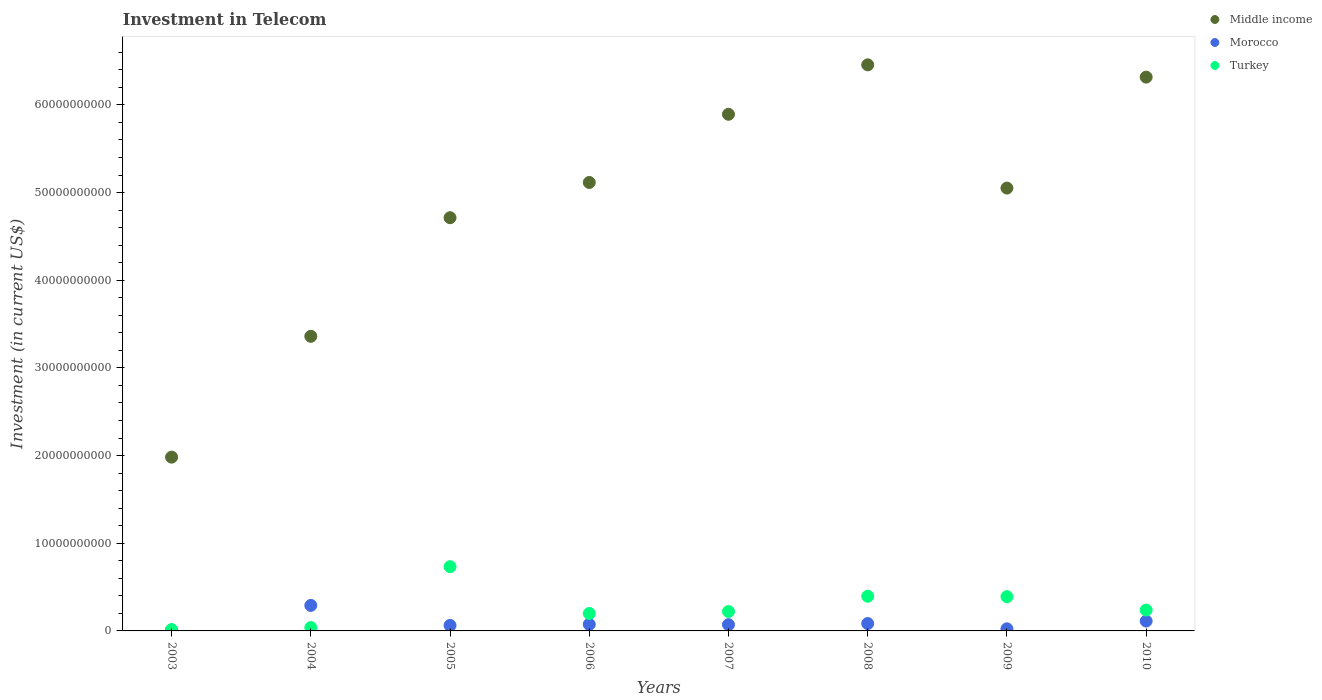Is the number of dotlines equal to the number of legend labels?
Give a very brief answer. Yes. What is the amount invested in telecom in Middle income in 2009?
Make the answer very short. 5.05e+1. Across all years, what is the maximum amount invested in telecom in Middle income?
Provide a short and direct response. 6.46e+1. Across all years, what is the minimum amount invested in telecom in Middle income?
Provide a short and direct response. 1.98e+1. In which year was the amount invested in telecom in Turkey maximum?
Provide a succinct answer. 2005. In which year was the amount invested in telecom in Turkey minimum?
Your answer should be compact. 2003. What is the total amount invested in telecom in Turkey in the graph?
Your answer should be very brief. 2.23e+1. What is the difference between the amount invested in telecom in Turkey in 2003 and that in 2005?
Your answer should be compact. -7.17e+09. What is the difference between the amount invested in telecom in Middle income in 2008 and the amount invested in telecom in Turkey in 2010?
Your answer should be compact. 6.22e+1. What is the average amount invested in telecom in Turkey per year?
Provide a succinct answer. 2.79e+09. In the year 2009, what is the difference between the amount invested in telecom in Morocco and amount invested in telecom in Turkey?
Your response must be concise. -3.67e+09. What is the ratio of the amount invested in telecom in Turkey in 2007 to that in 2009?
Offer a very short reply. 0.57. Is the amount invested in telecom in Middle income in 2003 less than that in 2004?
Your answer should be compact. Yes. What is the difference between the highest and the second highest amount invested in telecom in Morocco?
Your answer should be very brief. 1.79e+09. What is the difference between the highest and the lowest amount invested in telecom in Turkey?
Keep it short and to the point. 7.17e+09. In how many years, is the amount invested in telecom in Middle income greater than the average amount invested in telecom in Middle income taken over all years?
Offer a very short reply. 5. How many years are there in the graph?
Your answer should be compact. 8. What is the difference between two consecutive major ticks on the Y-axis?
Your answer should be very brief. 1.00e+1. Are the values on the major ticks of Y-axis written in scientific E-notation?
Your response must be concise. No. Does the graph contain any zero values?
Ensure brevity in your answer.  No. Does the graph contain grids?
Offer a very short reply. No. What is the title of the graph?
Ensure brevity in your answer.  Investment in Telecom. Does "Central African Republic" appear as one of the legend labels in the graph?
Provide a short and direct response. No. What is the label or title of the X-axis?
Make the answer very short. Years. What is the label or title of the Y-axis?
Provide a succinct answer. Investment (in current US$). What is the Investment (in current US$) in Middle income in 2003?
Provide a succinct answer. 1.98e+1. What is the Investment (in current US$) of Turkey in 2003?
Offer a very short reply. 1.55e+08. What is the Investment (in current US$) in Middle income in 2004?
Offer a very short reply. 3.36e+1. What is the Investment (in current US$) in Morocco in 2004?
Offer a terse response. 2.91e+09. What is the Investment (in current US$) of Turkey in 2004?
Your answer should be compact. 3.84e+08. What is the Investment (in current US$) of Middle income in 2005?
Offer a very short reply. 4.71e+1. What is the Investment (in current US$) of Morocco in 2005?
Ensure brevity in your answer.  6.26e+08. What is the Investment (in current US$) in Turkey in 2005?
Offer a terse response. 7.33e+09. What is the Investment (in current US$) of Middle income in 2006?
Provide a succinct answer. 5.12e+1. What is the Investment (in current US$) in Morocco in 2006?
Your answer should be compact. 7.51e+08. What is the Investment (in current US$) of Turkey in 2006?
Keep it short and to the point. 1.99e+09. What is the Investment (in current US$) of Middle income in 2007?
Provide a succinct answer. 5.89e+1. What is the Investment (in current US$) in Morocco in 2007?
Keep it short and to the point. 7.16e+08. What is the Investment (in current US$) in Turkey in 2007?
Give a very brief answer. 2.22e+09. What is the Investment (in current US$) in Middle income in 2008?
Give a very brief answer. 6.46e+1. What is the Investment (in current US$) of Morocco in 2008?
Provide a short and direct response. 8.43e+08. What is the Investment (in current US$) of Turkey in 2008?
Keep it short and to the point. 3.95e+09. What is the Investment (in current US$) of Middle income in 2009?
Keep it short and to the point. 5.05e+1. What is the Investment (in current US$) in Morocco in 2009?
Provide a succinct answer. 2.40e+08. What is the Investment (in current US$) of Turkey in 2009?
Offer a terse response. 3.91e+09. What is the Investment (in current US$) of Middle income in 2010?
Your answer should be compact. 6.32e+1. What is the Investment (in current US$) of Morocco in 2010?
Provide a succinct answer. 1.12e+09. What is the Investment (in current US$) of Turkey in 2010?
Your answer should be very brief. 2.38e+09. Across all years, what is the maximum Investment (in current US$) of Middle income?
Ensure brevity in your answer.  6.46e+1. Across all years, what is the maximum Investment (in current US$) of Morocco?
Offer a very short reply. 2.91e+09. Across all years, what is the maximum Investment (in current US$) of Turkey?
Offer a terse response. 7.33e+09. Across all years, what is the minimum Investment (in current US$) of Middle income?
Ensure brevity in your answer.  1.98e+1. Across all years, what is the minimum Investment (in current US$) of Turkey?
Give a very brief answer. 1.55e+08. What is the total Investment (in current US$) in Middle income in the graph?
Offer a terse response. 3.89e+11. What is the total Investment (in current US$) of Morocco in the graph?
Provide a succinct answer. 7.31e+09. What is the total Investment (in current US$) of Turkey in the graph?
Your answer should be compact. 2.23e+1. What is the difference between the Investment (in current US$) in Middle income in 2003 and that in 2004?
Your answer should be compact. -1.38e+1. What is the difference between the Investment (in current US$) of Morocco in 2003 and that in 2004?
Provide a short and direct response. -2.81e+09. What is the difference between the Investment (in current US$) in Turkey in 2003 and that in 2004?
Keep it short and to the point. -2.29e+08. What is the difference between the Investment (in current US$) in Middle income in 2003 and that in 2005?
Offer a terse response. -2.73e+1. What is the difference between the Investment (in current US$) in Morocco in 2003 and that in 2005?
Provide a short and direct response. -5.26e+08. What is the difference between the Investment (in current US$) in Turkey in 2003 and that in 2005?
Your answer should be compact. -7.17e+09. What is the difference between the Investment (in current US$) in Middle income in 2003 and that in 2006?
Make the answer very short. -3.13e+1. What is the difference between the Investment (in current US$) of Morocco in 2003 and that in 2006?
Give a very brief answer. -6.51e+08. What is the difference between the Investment (in current US$) in Turkey in 2003 and that in 2006?
Provide a succinct answer. -1.84e+09. What is the difference between the Investment (in current US$) in Middle income in 2003 and that in 2007?
Provide a succinct answer. -3.91e+1. What is the difference between the Investment (in current US$) in Morocco in 2003 and that in 2007?
Make the answer very short. -6.16e+08. What is the difference between the Investment (in current US$) of Turkey in 2003 and that in 2007?
Make the answer very short. -2.06e+09. What is the difference between the Investment (in current US$) in Middle income in 2003 and that in 2008?
Offer a terse response. -4.48e+1. What is the difference between the Investment (in current US$) of Morocco in 2003 and that in 2008?
Provide a succinct answer. -7.43e+08. What is the difference between the Investment (in current US$) of Turkey in 2003 and that in 2008?
Your answer should be very brief. -3.80e+09. What is the difference between the Investment (in current US$) of Middle income in 2003 and that in 2009?
Ensure brevity in your answer.  -3.07e+1. What is the difference between the Investment (in current US$) in Morocco in 2003 and that in 2009?
Offer a terse response. -1.40e+08. What is the difference between the Investment (in current US$) in Turkey in 2003 and that in 2009?
Give a very brief answer. -3.75e+09. What is the difference between the Investment (in current US$) in Middle income in 2003 and that in 2010?
Ensure brevity in your answer.  -4.34e+1. What is the difference between the Investment (in current US$) of Morocco in 2003 and that in 2010?
Keep it short and to the point. -1.02e+09. What is the difference between the Investment (in current US$) in Turkey in 2003 and that in 2010?
Provide a succinct answer. -2.23e+09. What is the difference between the Investment (in current US$) in Middle income in 2004 and that in 2005?
Keep it short and to the point. -1.35e+1. What is the difference between the Investment (in current US$) of Morocco in 2004 and that in 2005?
Provide a short and direct response. 2.28e+09. What is the difference between the Investment (in current US$) of Turkey in 2004 and that in 2005?
Offer a terse response. -6.95e+09. What is the difference between the Investment (in current US$) in Middle income in 2004 and that in 2006?
Give a very brief answer. -1.75e+1. What is the difference between the Investment (in current US$) of Morocco in 2004 and that in 2006?
Your response must be concise. 2.16e+09. What is the difference between the Investment (in current US$) of Turkey in 2004 and that in 2006?
Your answer should be very brief. -1.61e+09. What is the difference between the Investment (in current US$) in Middle income in 2004 and that in 2007?
Your answer should be compact. -2.53e+1. What is the difference between the Investment (in current US$) in Morocco in 2004 and that in 2007?
Ensure brevity in your answer.  2.19e+09. What is the difference between the Investment (in current US$) in Turkey in 2004 and that in 2007?
Give a very brief answer. -1.83e+09. What is the difference between the Investment (in current US$) of Middle income in 2004 and that in 2008?
Offer a very short reply. -3.10e+1. What is the difference between the Investment (in current US$) of Morocco in 2004 and that in 2008?
Give a very brief answer. 2.07e+09. What is the difference between the Investment (in current US$) in Turkey in 2004 and that in 2008?
Provide a short and direct response. -3.57e+09. What is the difference between the Investment (in current US$) of Middle income in 2004 and that in 2009?
Keep it short and to the point. -1.69e+1. What is the difference between the Investment (in current US$) in Morocco in 2004 and that in 2009?
Offer a very short reply. 2.67e+09. What is the difference between the Investment (in current US$) of Turkey in 2004 and that in 2009?
Offer a very short reply. -3.52e+09. What is the difference between the Investment (in current US$) in Middle income in 2004 and that in 2010?
Ensure brevity in your answer.  -2.96e+1. What is the difference between the Investment (in current US$) in Morocco in 2004 and that in 2010?
Your answer should be compact. 1.79e+09. What is the difference between the Investment (in current US$) in Turkey in 2004 and that in 2010?
Provide a succinct answer. -2.00e+09. What is the difference between the Investment (in current US$) of Middle income in 2005 and that in 2006?
Provide a short and direct response. -4.02e+09. What is the difference between the Investment (in current US$) in Morocco in 2005 and that in 2006?
Your response must be concise. -1.25e+08. What is the difference between the Investment (in current US$) of Turkey in 2005 and that in 2006?
Provide a short and direct response. 5.34e+09. What is the difference between the Investment (in current US$) of Middle income in 2005 and that in 2007?
Make the answer very short. -1.18e+1. What is the difference between the Investment (in current US$) in Morocco in 2005 and that in 2007?
Your answer should be compact. -9.00e+07. What is the difference between the Investment (in current US$) of Turkey in 2005 and that in 2007?
Provide a short and direct response. 5.11e+09. What is the difference between the Investment (in current US$) in Middle income in 2005 and that in 2008?
Give a very brief answer. -1.74e+1. What is the difference between the Investment (in current US$) of Morocco in 2005 and that in 2008?
Offer a very short reply. -2.17e+08. What is the difference between the Investment (in current US$) in Turkey in 2005 and that in 2008?
Your answer should be very brief. 3.37e+09. What is the difference between the Investment (in current US$) of Middle income in 2005 and that in 2009?
Provide a short and direct response. -3.38e+09. What is the difference between the Investment (in current US$) in Morocco in 2005 and that in 2009?
Provide a short and direct response. 3.86e+08. What is the difference between the Investment (in current US$) of Turkey in 2005 and that in 2009?
Provide a short and direct response. 3.42e+09. What is the difference between the Investment (in current US$) of Middle income in 2005 and that in 2010?
Provide a short and direct response. -1.60e+1. What is the difference between the Investment (in current US$) in Morocco in 2005 and that in 2010?
Keep it short and to the point. -4.98e+08. What is the difference between the Investment (in current US$) in Turkey in 2005 and that in 2010?
Your answer should be very brief. 4.95e+09. What is the difference between the Investment (in current US$) of Middle income in 2006 and that in 2007?
Ensure brevity in your answer.  -7.78e+09. What is the difference between the Investment (in current US$) of Morocco in 2006 and that in 2007?
Offer a terse response. 3.46e+07. What is the difference between the Investment (in current US$) in Turkey in 2006 and that in 2007?
Offer a very short reply. -2.23e+08. What is the difference between the Investment (in current US$) in Middle income in 2006 and that in 2008?
Your response must be concise. -1.34e+1. What is the difference between the Investment (in current US$) in Morocco in 2006 and that in 2008?
Offer a very short reply. -9.24e+07. What is the difference between the Investment (in current US$) of Turkey in 2006 and that in 2008?
Offer a very short reply. -1.96e+09. What is the difference between the Investment (in current US$) in Middle income in 2006 and that in 2009?
Offer a terse response. 6.40e+08. What is the difference between the Investment (in current US$) in Morocco in 2006 and that in 2009?
Your response must be concise. 5.11e+08. What is the difference between the Investment (in current US$) in Turkey in 2006 and that in 2009?
Offer a very short reply. -1.92e+09. What is the difference between the Investment (in current US$) in Middle income in 2006 and that in 2010?
Ensure brevity in your answer.  -1.20e+1. What is the difference between the Investment (in current US$) in Morocco in 2006 and that in 2010?
Keep it short and to the point. -3.73e+08. What is the difference between the Investment (in current US$) in Turkey in 2006 and that in 2010?
Offer a terse response. -3.89e+08. What is the difference between the Investment (in current US$) in Middle income in 2007 and that in 2008?
Your answer should be compact. -5.64e+09. What is the difference between the Investment (in current US$) of Morocco in 2007 and that in 2008?
Your response must be concise. -1.27e+08. What is the difference between the Investment (in current US$) of Turkey in 2007 and that in 2008?
Make the answer very short. -1.74e+09. What is the difference between the Investment (in current US$) of Middle income in 2007 and that in 2009?
Your response must be concise. 8.42e+09. What is the difference between the Investment (in current US$) in Morocco in 2007 and that in 2009?
Your answer should be compact. 4.76e+08. What is the difference between the Investment (in current US$) of Turkey in 2007 and that in 2009?
Your answer should be very brief. -1.69e+09. What is the difference between the Investment (in current US$) of Middle income in 2007 and that in 2010?
Offer a terse response. -4.24e+09. What is the difference between the Investment (in current US$) of Morocco in 2007 and that in 2010?
Your answer should be very brief. -4.08e+08. What is the difference between the Investment (in current US$) of Turkey in 2007 and that in 2010?
Make the answer very short. -1.66e+08. What is the difference between the Investment (in current US$) in Middle income in 2008 and that in 2009?
Provide a short and direct response. 1.41e+1. What is the difference between the Investment (in current US$) of Morocco in 2008 and that in 2009?
Offer a very short reply. 6.03e+08. What is the difference between the Investment (in current US$) in Turkey in 2008 and that in 2009?
Your answer should be very brief. 4.60e+07. What is the difference between the Investment (in current US$) in Middle income in 2008 and that in 2010?
Your response must be concise. 1.40e+09. What is the difference between the Investment (in current US$) of Morocco in 2008 and that in 2010?
Offer a terse response. -2.81e+08. What is the difference between the Investment (in current US$) of Turkey in 2008 and that in 2010?
Ensure brevity in your answer.  1.57e+09. What is the difference between the Investment (in current US$) in Middle income in 2009 and that in 2010?
Your response must be concise. -1.27e+1. What is the difference between the Investment (in current US$) of Morocco in 2009 and that in 2010?
Keep it short and to the point. -8.84e+08. What is the difference between the Investment (in current US$) of Turkey in 2009 and that in 2010?
Give a very brief answer. 1.53e+09. What is the difference between the Investment (in current US$) of Middle income in 2003 and the Investment (in current US$) of Morocco in 2004?
Your answer should be very brief. 1.69e+1. What is the difference between the Investment (in current US$) in Middle income in 2003 and the Investment (in current US$) in Turkey in 2004?
Offer a terse response. 1.94e+1. What is the difference between the Investment (in current US$) of Morocco in 2003 and the Investment (in current US$) of Turkey in 2004?
Your answer should be very brief. -2.84e+08. What is the difference between the Investment (in current US$) in Middle income in 2003 and the Investment (in current US$) in Morocco in 2005?
Make the answer very short. 1.92e+1. What is the difference between the Investment (in current US$) of Middle income in 2003 and the Investment (in current US$) of Turkey in 2005?
Offer a very short reply. 1.25e+1. What is the difference between the Investment (in current US$) in Morocco in 2003 and the Investment (in current US$) in Turkey in 2005?
Keep it short and to the point. -7.23e+09. What is the difference between the Investment (in current US$) in Middle income in 2003 and the Investment (in current US$) in Morocco in 2006?
Your response must be concise. 1.91e+1. What is the difference between the Investment (in current US$) of Middle income in 2003 and the Investment (in current US$) of Turkey in 2006?
Your answer should be very brief. 1.78e+1. What is the difference between the Investment (in current US$) of Morocco in 2003 and the Investment (in current US$) of Turkey in 2006?
Your answer should be compact. -1.89e+09. What is the difference between the Investment (in current US$) of Middle income in 2003 and the Investment (in current US$) of Morocco in 2007?
Make the answer very short. 1.91e+1. What is the difference between the Investment (in current US$) in Middle income in 2003 and the Investment (in current US$) in Turkey in 2007?
Offer a very short reply. 1.76e+1. What is the difference between the Investment (in current US$) in Morocco in 2003 and the Investment (in current US$) in Turkey in 2007?
Offer a terse response. -2.12e+09. What is the difference between the Investment (in current US$) in Middle income in 2003 and the Investment (in current US$) in Morocco in 2008?
Ensure brevity in your answer.  1.90e+1. What is the difference between the Investment (in current US$) in Middle income in 2003 and the Investment (in current US$) in Turkey in 2008?
Your response must be concise. 1.59e+1. What is the difference between the Investment (in current US$) in Morocco in 2003 and the Investment (in current US$) in Turkey in 2008?
Your response must be concise. -3.85e+09. What is the difference between the Investment (in current US$) in Middle income in 2003 and the Investment (in current US$) in Morocco in 2009?
Your response must be concise. 1.96e+1. What is the difference between the Investment (in current US$) of Middle income in 2003 and the Investment (in current US$) of Turkey in 2009?
Your answer should be very brief. 1.59e+1. What is the difference between the Investment (in current US$) of Morocco in 2003 and the Investment (in current US$) of Turkey in 2009?
Keep it short and to the point. -3.81e+09. What is the difference between the Investment (in current US$) in Middle income in 2003 and the Investment (in current US$) in Morocco in 2010?
Your response must be concise. 1.87e+1. What is the difference between the Investment (in current US$) of Middle income in 2003 and the Investment (in current US$) of Turkey in 2010?
Make the answer very short. 1.74e+1. What is the difference between the Investment (in current US$) in Morocco in 2003 and the Investment (in current US$) in Turkey in 2010?
Make the answer very short. -2.28e+09. What is the difference between the Investment (in current US$) of Middle income in 2004 and the Investment (in current US$) of Morocco in 2005?
Offer a terse response. 3.30e+1. What is the difference between the Investment (in current US$) in Middle income in 2004 and the Investment (in current US$) in Turkey in 2005?
Offer a very short reply. 2.63e+1. What is the difference between the Investment (in current US$) of Morocco in 2004 and the Investment (in current US$) of Turkey in 2005?
Give a very brief answer. -4.42e+09. What is the difference between the Investment (in current US$) in Middle income in 2004 and the Investment (in current US$) in Morocco in 2006?
Offer a very short reply. 3.29e+1. What is the difference between the Investment (in current US$) in Middle income in 2004 and the Investment (in current US$) in Turkey in 2006?
Provide a succinct answer. 3.16e+1. What is the difference between the Investment (in current US$) of Morocco in 2004 and the Investment (in current US$) of Turkey in 2006?
Give a very brief answer. 9.19e+08. What is the difference between the Investment (in current US$) in Middle income in 2004 and the Investment (in current US$) in Morocco in 2007?
Your answer should be compact. 3.29e+1. What is the difference between the Investment (in current US$) of Middle income in 2004 and the Investment (in current US$) of Turkey in 2007?
Your answer should be compact. 3.14e+1. What is the difference between the Investment (in current US$) of Morocco in 2004 and the Investment (in current US$) of Turkey in 2007?
Offer a very short reply. 6.96e+08. What is the difference between the Investment (in current US$) in Middle income in 2004 and the Investment (in current US$) in Morocco in 2008?
Give a very brief answer. 3.28e+1. What is the difference between the Investment (in current US$) of Middle income in 2004 and the Investment (in current US$) of Turkey in 2008?
Your answer should be very brief. 2.97e+1. What is the difference between the Investment (in current US$) of Morocco in 2004 and the Investment (in current US$) of Turkey in 2008?
Your answer should be compact. -1.04e+09. What is the difference between the Investment (in current US$) of Middle income in 2004 and the Investment (in current US$) of Morocco in 2009?
Ensure brevity in your answer.  3.34e+1. What is the difference between the Investment (in current US$) in Middle income in 2004 and the Investment (in current US$) in Turkey in 2009?
Your answer should be very brief. 2.97e+1. What is the difference between the Investment (in current US$) of Morocco in 2004 and the Investment (in current US$) of Turkey in 2009?
Give a very brief answer. -9.98e+08. What is the difference between the Investment (in current US$) in Middle income in 2004 and the Investment (in current US$) in Morocco in 2010?
Provide a short and direct response. 3.25e+1. What is the difference between the Investment (in current US$) in Middle income in 2004 and the Investment (in current US$) in Turkey in 2010?
Your answer should be compact. 3.12e+1. What is the difference between the Investment (in current US$) of Morocco in 2004 and the Investment (in current US$) of Turkey in 2010?
Offer a very short reply. 5.30e+08. What is the difference between the Investment (in current US$) in Middle income in 2005 and the Investment (in current US$) in Morocco in 2006?
Give a very brief answer. 4.64e+1. What is the difference between the Investment (in current US$) in Middle income in 2005 and the Investment (in current US$) in Turkey in 2006?
Give a very brief answer. 4.51e+1. What is the difference between the Investment (in current US$) in Morocco in 2005 and the Investment (in current US$) in Turkey in 2006?
Offer a terse response. -1.37e+09. What is the difference between the Investment (in current US$) of Middle income in 2005 and the Investment (in current US$) of Morocco in 2007?
Your answer should be very brief. 4.64e+1. What is the difference between the Investment (in current US$) in Middle income in 2005 and the Investment (in current US$) in Turkey in 2007?
Provide a succinct answer. 4.49e+1. What is the difference between the Investment (in current US$) of Morocco in 2005 and the Investment (in current US$) of Turkey in 2007?
Provide a succinct answer. -1.59e+09. What is the difference between the Investment (in current US$) in Middle income in 2005 and the Investment (in current US$) in Morocco in 2008?
Give a very brief answer. 4.63e+1. What is the difference between the Investment (in current US$) in Middle income in 2005 and the Investment (in current US$) in Turkey in 2008?
Provide a short and direct response. 4.32e+1. What is the difference between the Investment (in current US$) in Morocco in 2005 and the Investment (in current US$) in Turkey in 2008?
Your answer should be compact. -3.33e+09. What is the difference between the Investment (in current US$) in Middle income in 2005 and the Investment (in current US$) in Morocco in 2009?
Offer a very short reply. 4.69e+1. What is the difference between the Investment (in current US$) in Middle income in 2005 and the Investment (in current US$) in Turkey in 2009?
Give a very brief answer. 4.32e+1. What is the difference between the Investment (in current US$) of Morocco in 2005 and the Investment (in current US$) of Turkey in 2009?
Ensure brevity in your answer.  -3.28e+09. What is the difference between the Investment (in current US$) in Middle income in 2005 and the Investment (in current US$) in Morocco in 2010?
Provide a short and direct response. 4.60e+1. What is the difference between the Investment (in current US$) of Middle income in 2005 and the Investment (in current US$) of Turkey in 2010?
Offer a very short reply. 4.48e+1. What is the difference between the Investment (in current US$) of Morocco in 2005 and the Investment (in current US$) of Turkey in 2010?
Give a very brief answer. -1.75e+09. What is the difference between the Investment (in current US$) of Middle income in 2006 and the Investment (in current US$) of Morocco in 2007?
Ensure brevity in your answer.  5.04e+1. What is the difference between the Investment (in current US$) in Middle income in 2006 and the Investment (in current US$) in Turkey in 2007?
Your response must be concise. 4.89e+1. What is the difference between the Investment (in current US$) in Morocco in 2006 and the Investment (in current US$) in Turkey in 2007?
Keep it short and to the point. -1.46e+09. What is the difference between the Investment (in current US$) in Middle income in 2006 and the Investment (in current US$) in Morocco in 2008?
Your response must be concise. 5.03e+1. What is the difference between the Investment (in current US$) of Middle income in 2006 and the Investment (in current US$) of Turkey in 2008?
Offer a very short reply. 4.72e+1. What is the difference between the Investment (in current US$) in Morocco in 2006 and the Investment (in current US$) in Turkey in 2008?
Ensure brevity in your answer.  -3.20e+09. What is the difference between the Investment (in current US$) of Middle income in 2006 and the Investment (in current US$) of Morocco in 2009?
Give a very brief answer. 5.09e+1. What is the difference between the Investment (in current US$) in Middle income in 2006 and the Investment (in current US$) in Turkey in 2009?
Provide a short and direct response. 4.72e+1. What is the difference between the Investment (in current US$) in Morocco in 2006 and the Investment (in current US$) in Turkey in 2009?
Ensure brevity in your answer.  -3.16e+09. What is the difference between the Investment (in current US$) in Middle income in 2006 and the Investment (in current US$) in Morocco in 2010?
Your answer should be compact. 5.00e+1. What is the difference between the Investment (in current US$) in Middle income in 2006 and the Investment (in current US$) in Turkey in 2010?
Keep it short and to the point. 4.88e+1. What is the difference between the Investment (in current US$) of Morocco in 2006 and the Investment (in current US$) of Turkey in 2010?
Your answer should be very brief. -1.63e+09. What is the difference between the Investment (in current US$) in Middle income in 2007 and the Investment (in current US$) in Morocco in 2008?
Provide a succinct answer. 5.81e+1. What is the difference between the Investment (in current US$) in Middle income in 2007 and the Investment (in current US$) in Turkey in 2008?
Offer a very short reply. 5.50e+1. What is the difference between the Investment (in current US$) in Morocco in 2007 and the Investment (in current US$) in Turkey in 2008?
Your answer should be very brief. -3.24e+09. What is the difference between the Investment (in current US$) in Middle income in 2007 and the Investment (in current US$) in Morocco in 2009?
Offer a very short reply. 5.87e+1. What is the difference between the Investment (in current US$) of Middle income in 2007 and the Investment (in current US$) of Turkey in 2009?
Offer a terse response. 5.50e+1. What is the difference between the Investment (in current US$) of Morocco in 2007 and the Investment (in current US$) of Turkey in 2009?
Offer a very short reply. -3.19e+09. What is the difference between the Investment (in current US$) in Middle income in 2007 and the Investment (in current US$) in Morocco in 2010?
Provide a short and direct response. 5.78e+1. What is the difference between the Investment (in current US$) of Middle income in 2007 and the Investment (in current US$) of Turkey in 2010?
Make the answer very short. 5.66e+1. What is the difference between the Investment (in current US$) of Morocco in 2007 and the Investment (in current US$) of Turkey in 2010?
Offer a terse response. -1.66e+09. What is the difference between the Investment (in current US$) in Middle income in 2008 and the Investment (in current US$) in Morocco in 2009?
Your answer should be compact. 6.43e+1. What is the difference between the Investment (in current US$) of Middle income in 2008 and the Investment (in current US$) of Turkey in 2009?
Offer a terse response. 6.07e+1. What is the difference between the Investment (in current US$) of Morocco in 2008 and the Investment (in current US$) of Turkey in 2009?
Ensure brevity in your answer.  -3.06e+09. What is the difference between the Investment (in current US$) in Middle income in 2008 and the Investment (in current US$) in Morocco in 2010?
Offer a terse response. 6.34e+1. What is the difference between the Investment (in current US$) in Middle income in 2008 and the Investment (in current US$) in Turkey in 2010?
Offer a terse response. 6.22e+1. What is the difference between the Investment (in current US$) of Morocco in 2008 and the Investment (in current US$) of Turkey in 2010?
Make the answer very short. -1.54e+09. What is the difference between the Investment (in current US$) in Middle income in 2009 and the Investment (in current US$) in Morocco in 2010?
Provide a short and direct response. 4.94e+1. What is the difference between the Investment (in current US$) of Middle income in 2009 and the Investment (in current US$) of Turkey in 2010?
Offer a very short reply. 4.81e+1. What is the difference between the Investment (in current US$) in Morocco in 2009 and the Investment (in current US$) in Turkey in 2010?
Provide a succinct answer. -2.14e+09. What is the average Investment (in current US$) in Middle income per year?
Keep it short and to the point. 4.86e+1. What is the average Investment (in current US$) in Morocco per year?
Provide a short and direct response. 9.14e+08. What is the average Investment (in current US$) in Turkey per year?
Your answer should be compact. 2.79e+09. In the year 2003, what is the difference between the Investment (in current US$) of Middle income and Investment (in current US$) of Morocco?
Offer a very short reply. 1.97e+1. In the year 2003, what is the difference between the Investment (in current US$) of Middle income and Investment (in current US$) of Turkey?
Offer a terse response. 1.97e+1. In the year 2003, what is the difference between the Investment (in current US$) of Morocco and Investment (in current US$) of Turkey?
Your response must be concise. -5.50e+07. In the year 2004, what is the difference between the Investment (in current US$) in Middle income and Investment (in current US$) in Morocco?
Ensure brevity in your answer.  3.07e+1. In the year 2004, what is the difference between the Investment (in current US$) in Middle income and Investment (in current US$) in Turkey?
Ensure brevity in your answer.  3.32e+1. In the year 2004, what is the difference between the Investment (in current US$) in Morocco and Investment (in current US$) in Turkey?
Keep it short and to the point. 2.53e+09. In the year 2005, what is the difference between the Investment (in current US$) in Middle income and Investment (in current US$) in Morocco?
Offer a terse response. 4.65e+1. In the year 2005, what is the difference between the Investment (in current US$) in Middle income and Investment (in current US$) in Turkey?
Offer a very short reply. 3.98e+1. In the year 2005, what is the difference between the Investment (in current US$) of Morocco and Investment (in current US$) of Turkey?
Offer a very short reply. -6.70e+09. In the year 2006, what is the difference between the Investment (in current US$) of Middle income and Investment (in current US$) of Morocco?
Ensure brevity in your answer.  5.04e+1. In the year 2006, what is the difference between the Investment (in current US$) of Middle income and Investment (in current US$) of Turkey?
Ensure brevity in your answer.  4.92e+1. In the year 2006, what is the difference between the Investment (in current US$) in Morocco and Investment (in current US$) in Turkey?
Give a very brief answer. -1.24e+09. In the year 2007, what is the difference between the Investment (in current US$) in Middle income and Investment (in current US$) in Morocco?
Make the answer very short. 5.82e+1. In the year 2007, what is the difference between the Investment (in current US$) in Middle income and Investment (in current US$) in Turkey?
Keep it short and to the point. 5.67e+1. In the year 2007, what is the difference between the Investment (in current US$) in Morocco and Investment (in current US$) in Turkey?
Offer a very short reply. -1.50e+09. In the year 2008, what is the difference between the Investment (in current US$) in Middle income and Investment (in current US$) in Morocco?
Your answer should be very brief. 6.37e+1. In the year 2008, what is the difference between the Investment (in current US$) of Middle income and Investment (in current US$) of Turkey?
Your answer should be very brief. 6.06e+1. In the year 2008, what is the difference between the Investment (in current US$) in Morocco and Investment (in current US$) in Turkey?
Provide a short and direct response. -3.11e+09. In the year 2009, what is the difference between the Investment (in current US$) in Middle income and Investment (in current US$) in Morocco?
Keep it short and to the point. 5.03e+1. In the year 2009, what is the difference between the Investment (in current US$) of Middle income and Investment (in current US$) of Turkey?
Your answer should be compact. 4.66e+1. In the year 2009, what is the difference between the Investment (in current US$) in Morocco and Investment (in current US$) in Turkey?
Offer a very short reply. -3.67e+09. In the year 2010, what is the difference between the Investment (in current US$) in Middle income and Investment (in current US$) in Morocco?
Offer a very short reply. 6.20e+1. In the year 2010, what is the difference between the Investment (in current US$) of Middle income and Investment (in current US$) of Turkey?
Ensure brevity in your answer.  6.08e+1. In the year 2010, what is the difference between the Investment (in current US$) of Morocco and Investment (in current US$) of Turkey?
Provide a succinct answer. -1.26e+09. What is the ratio of the Investment (in current US$) in Middle income in 2003 to that in 2004?
Your answer should be very brief. 0.59. What is the ratio of the Investment (in current US$) of Morocco in 2003 to that in 2004?
Offer a terse response. 0.03. What is the ratio of the Investment (in current US$) of Turkey in 2003 to that in 2004?
Your answer should be very brief. 0.4. What is the ratio of the Investment (in current US$) in Middle income in 2003 to that in 2005?
Your response must be concise. 0.42. What is the ratio of the Investment (in current US$) in Morocco in 2003 to that in 2005?
Ensure brevity in your answer.  0.16. What is the ratio of the Investment (in current US$) in Turkey in 2003 to that in 2005?
Make the answer very short. 0.02. What is the ratio of the Investment (in current US$) of Middle income in 2003 to that in 2006?
Your response must be concise. 0.39. What is the ratio of the Investment (in current US$) in Morocco in 2003 to that in 2006?
Give a very brief answer. 0.13. What is the ratio of the Investment (in current US$) of Turkey in 2003 to that in 2006?
Your answer should be compact. 0.08. What is the ratio of the Investment (in current US$) of Middle income in 2003 to that in 2007?
Make the answer very short. 0.34. What is the ratio of the Investment (in current US$) of Morocco in 2003 to that in 2007?
Your response must be concise. 0.14. What is the ratio of the Investment (in current US$) of Turkey in 2003 to that in 2007?
Your answer should be compact. 0.07. What is the ratio of the Investment (in current US$) of Middle income in 2003 to that in 2008?
Give a very brief answer. 0.31. What is the ratio of the Investment (in current US$) of Morocco in 2003 to that in 2008?
Offer a very short reply. 0.12. What is the ratio of the Investment (in current US$) of Turkey in 2003 to that in 2008?
Your answer should be compact. 0.04. What is the ratio of the Investment (in current US$) of Middle income in 2003 to that in 2009?
Your answer should be compact. 0.39. What is the ratio of the Investment (in current US$) of Morocco in 2003 to that in 2009?
Give a very brief answer. 0.42. What is the ratio of the Investment (in current US$) of Turkey in 2003 to that in 2009?
Your response must be concise. 0.04. What is the ratio of the Investment (in current US$) of Middle income in 2003 to that in 2010?
Your answer should be very brief. 0.31. What is the ratio of the Investment (in current US$) of Morocco in 2003 to that in 2010?
Offer a terse response. 0.09. What is the ratio of the Investment (in current US$) in Turkey in 2003 to that in 2010?
Your answer should be compact. 0.07. What is the ratio of the Investment (in current US$) of Middle income in 2004 to that in 2005?
Keep it short and to the point. 0.71. What is the ratio of the Investment (in current US$) of Morocco in 2004 to that in 2005?
Provide a short and direct response. 4.65. What is the ratio of the Investment (in current US$) of Turkey in 2004 to that in 2005?
Give a very brief answer. 0.05. What is the ratio of the Investment (in current US$) in Middle income in 2004 to that in 2006?
Offer a very short reply. 0.66. What is the ratio of the Investment (in current US$) of Morocco in 2004 to that in 2006?
Give a very brief answer. 3.88. What is the ratio of the Investment (in current US$) in Turkey in 2004 to that in 2006?
Offer a very short reply. 0.19. What is the ratio of the Investment (in current US$) of Middle income in 2004 to that in 2007?
Make the answer very short. 0.57. What is the ratio of the Investment (in current US$) in Morocco in 2004 to that in 2007?
Keep it short and to the point. 4.06. What is the ratio of the Investment (in current US$) in Turkey in 2004 to that in 2007?
Ensure brevity in your answer.  0.17. What is the ratio of the Investment (in current US$) of Middle income in 2004 to that in 2008?
Ensure brevity in your answer.  0.52. What is the ratio of the Investment (in current US$) of Morocco in 2004 to that in 2008?
Provide a short and direct response. 3.45. What is the ratio of the Investment (in current US$) in Turkey in 2004 to that in 2008?
Make the answer very short. 0.1. What is the ratio of the Investment (in current US$) of Middle income in 2004 to that in 2009?
Your response must be concise. 0.67. What is the ratio of the Investment (in current US$) in Morocco in 2004 to that in 2009?
Provide a short and direct response. 12.13. What is the ratio of the Investment (in current US$) of Turkey in 2004 to that in 2009?
Your answer should be compact. 0.1. What is the ratio of the Investment (in current US$) in Middle income in 2004 to that in 2010?
Provide a succinct answer. 0.53. What is the ratio of the Investment (in current US$) in Morocco in 2004 to that in 2010?
Keep it short and to the point. 2.59. What is the ratio of the Investment (in current US$) of Turkey in 2004 to that in 2010?
Ensure brevity in your answer.  0.16. What is the ratio of the Investment (in current US$) of Middle income in 2005 to that in 2006?
Give a very brief answer. 0.92. What is the ratio of the Investment (in current US$) in Morocco in 2005 to that in 2006?
Offer a terse response. 0.83. What is the ratio of the Investment (in current US$) of Turkey in 2005 to that in 2006?
Your answer should be compact. 3.68. What is the ratio of the Investment (in current US$) in Middle income in 2005 to that in 2007?
Make the answer very short. 0.8. What is the ratio of the Investment (in current US$) of Morocco in 2005 to that in 2007?
Ensure brevity in your answer.  0.87. What is the ratio of the Investment (in current US$) of Turkey in 2005 to that in 2007?
Offer a very short reply. 3.31. What is the ratio of the Investment (in current US$) in Middle income in 2005 to that in 2008?
Offer a very short reply. 0.73. What is the ratio of the Investment (in current US$) of Morocco in 2005 to that in 2008?
Give a very brief answer. 0.74. What is the ratio of the Investment (in current US$) in Turkey in 2005 to that in 2008?
Your answer should be very brief. 1.85. What is the ratio of the Investment (in current US$) of Middle income in 2005 to that in 2009?
Offer a very short reply. 0.93. What is the ratio of the Investment (in current US$) of Morocco in 2005 to that in 2009?
Give a very brief answer. 2.61. What is the ratio of the Investment (in current US$) in Turkey in 2005 to that in 2009?
Ensure brevity in your answer.  1.88. What is the ratio of the Investment (in current US$) of Middle income in 2005 to that in 2010?
Provide a succinct answer. 0.75. What is the ratio of the Investment (in current US$) in Morocco in 2005 to that in 2010?
Offer a terse response. 0.56. What is the ratio of the Investment (in current US$) of Turkey in 2005 to that in 2010?
Provide a short and direct response. 3.08. What is the ratio of the Investment (in current US$) of Middle income in 2006 to that in 2007?
Give a very brief answer. 0.87. What is the ratio of the Investment (in current US$) of Morocco in 2006 to that in 2007?
Keep it short and to the point. 1.05. What is the ratio of the Investment (in current US$) in Turkey in 2006 to that in 2007?
Provide a succinct answer. 0.9. What is the ratio of the Investment (in current US$) of Middle income in 2006 to that in 2008?
Make the answer very short. 0.79. What is the ratio of the Investment (in current US$) of Morocco in 2006 to that in 2008?
Offer a very short reply. 0.89. What is the ratio of the Investment (in current US$) of Turkey in 2006 to that in 2008?
Keep it short and to the point. 0.5. What is the ratio of the Investment (in current US$) of Middle income in 2006 to that in 2009?
Ensure brevity in your answer.  1.01. What is the ratio of the Investment (in current US$) of Morocco in 2006 to that in 2009?
Offer a very short reply. 3.13. What is the ratio of the Investment (in current US$) of Turkey in 2006 to that in 2009?
Your answer should be very brief. 0.51. What is the ratio of the Investment (in current US$) of Middle income in 2006 to that in 2010?
Offer a very short reply. 0.81. What is the ratio of the Investment (in current US$) in Morocco in 2006 to that in 2010?
Offer a terse response. 0.67. What is the ratio of the Investment (in current US$) of Turkey in 2006 to that in 2010?
Give a very brief answer. 0.84. What is the ratio of the Investment (in current US$) of Middle income in 2007 to that in 2008?
Your answer should be very brief. 0.91. What is the ratio of the Investment (in current US$) of Morocco in 2007 to that in 2008?
Your answer should be compact. 0.85. What is the ratio of the Investment (in current US$) of Turkey in 2007 to that in 2008?
Offer a very short reply. 0.56. What is the ratio of the Investment (in current US$) of Middle income in 2007 to that in 2009?
Keep it short and to the point. 1.17. What is the ratio of the Investment (in current US$) in Morocco in 2007 to that in 2009?
Keep it short and to the point. 2.98. What is the ratio of the Investment (in current US$) of Turkey in 2007 to that in 2009?
Provide a succinct answer. 0.57. What is the ratio of the Investment (in current US$) in Middle income in 2007 to that in 2010?
Keep it short and to the point. 0.93. What is the ratio of the Investment (in current US$) of Morocco in 2007 to that in 2010?
Give a very brief answer. 0.64. What is the ratio of the Investment (in current US$) in Turkey in 2007 to that in 2010?
Offer a terse response. 0.93. What is the ratio of the Investment (in current US$) of Middle income in 2008 to that in 2009?
Ensure brevity in your answer.  1.28. What is the ratio of the Investment (in current US$) in Morocco in 2008 to that in 2009?
Offer a very short reply. 3.51. What is the ratio of the Investment (in current US$) of Turkey in 2008 to that in 2009?
Offer a very short reply. 1.01. What is the ratio of the Investment (in current US$) in Middle income in 2008 to that in 2010?
Your answer should be compact. 1.02. What is the ratio of the Investment (in current US$) of Morocco in 2008 to that in 2010?
Your answer should be compact. 0.75. What is the ratio of the Investment (in current US$) of Turkey in 2008 to that in 2010?
Your answer should be compact. 1.66. What is the ratio of the Investment (in current US$) in Middle income in 2009 to that in 2010?
Give a very brief answer. 0.8. What is the ratio of the Investment (in current US$) in Morocco in 2009 to that in 2010?
Provide a succinct answer. 0.21. What is the ratio of the Investment (in current US$) in Turkey in 2009 to that in 2010?
Your response must be concise. 1.64. What is the difference between the highest and the second highest Investment (in current US$) in Middle income?
Make the answer very short. 1.40e+09. What is the difference between the highest and the second highest Investment (in current US$) of Morocco?
Make the answer very short. 1.79e+09. What is the difference between the highest and the second highest Investment (in current US$) in Turkey?
Make the answer very short. 3.37e+09. What is the difference between the highest and the lowest Investment (in current US$) of Middle income?
Offer a very short reply. 4.48e+1. What is the difference between the highest and the lowest Investment (in current US$) of Morocco?
Provide a short and direct response. 2.81e+09. What is the difference between the highest and the lowest Investment (in current US$) in Turkey?
Offer a very short reply. 7.17e+09. 